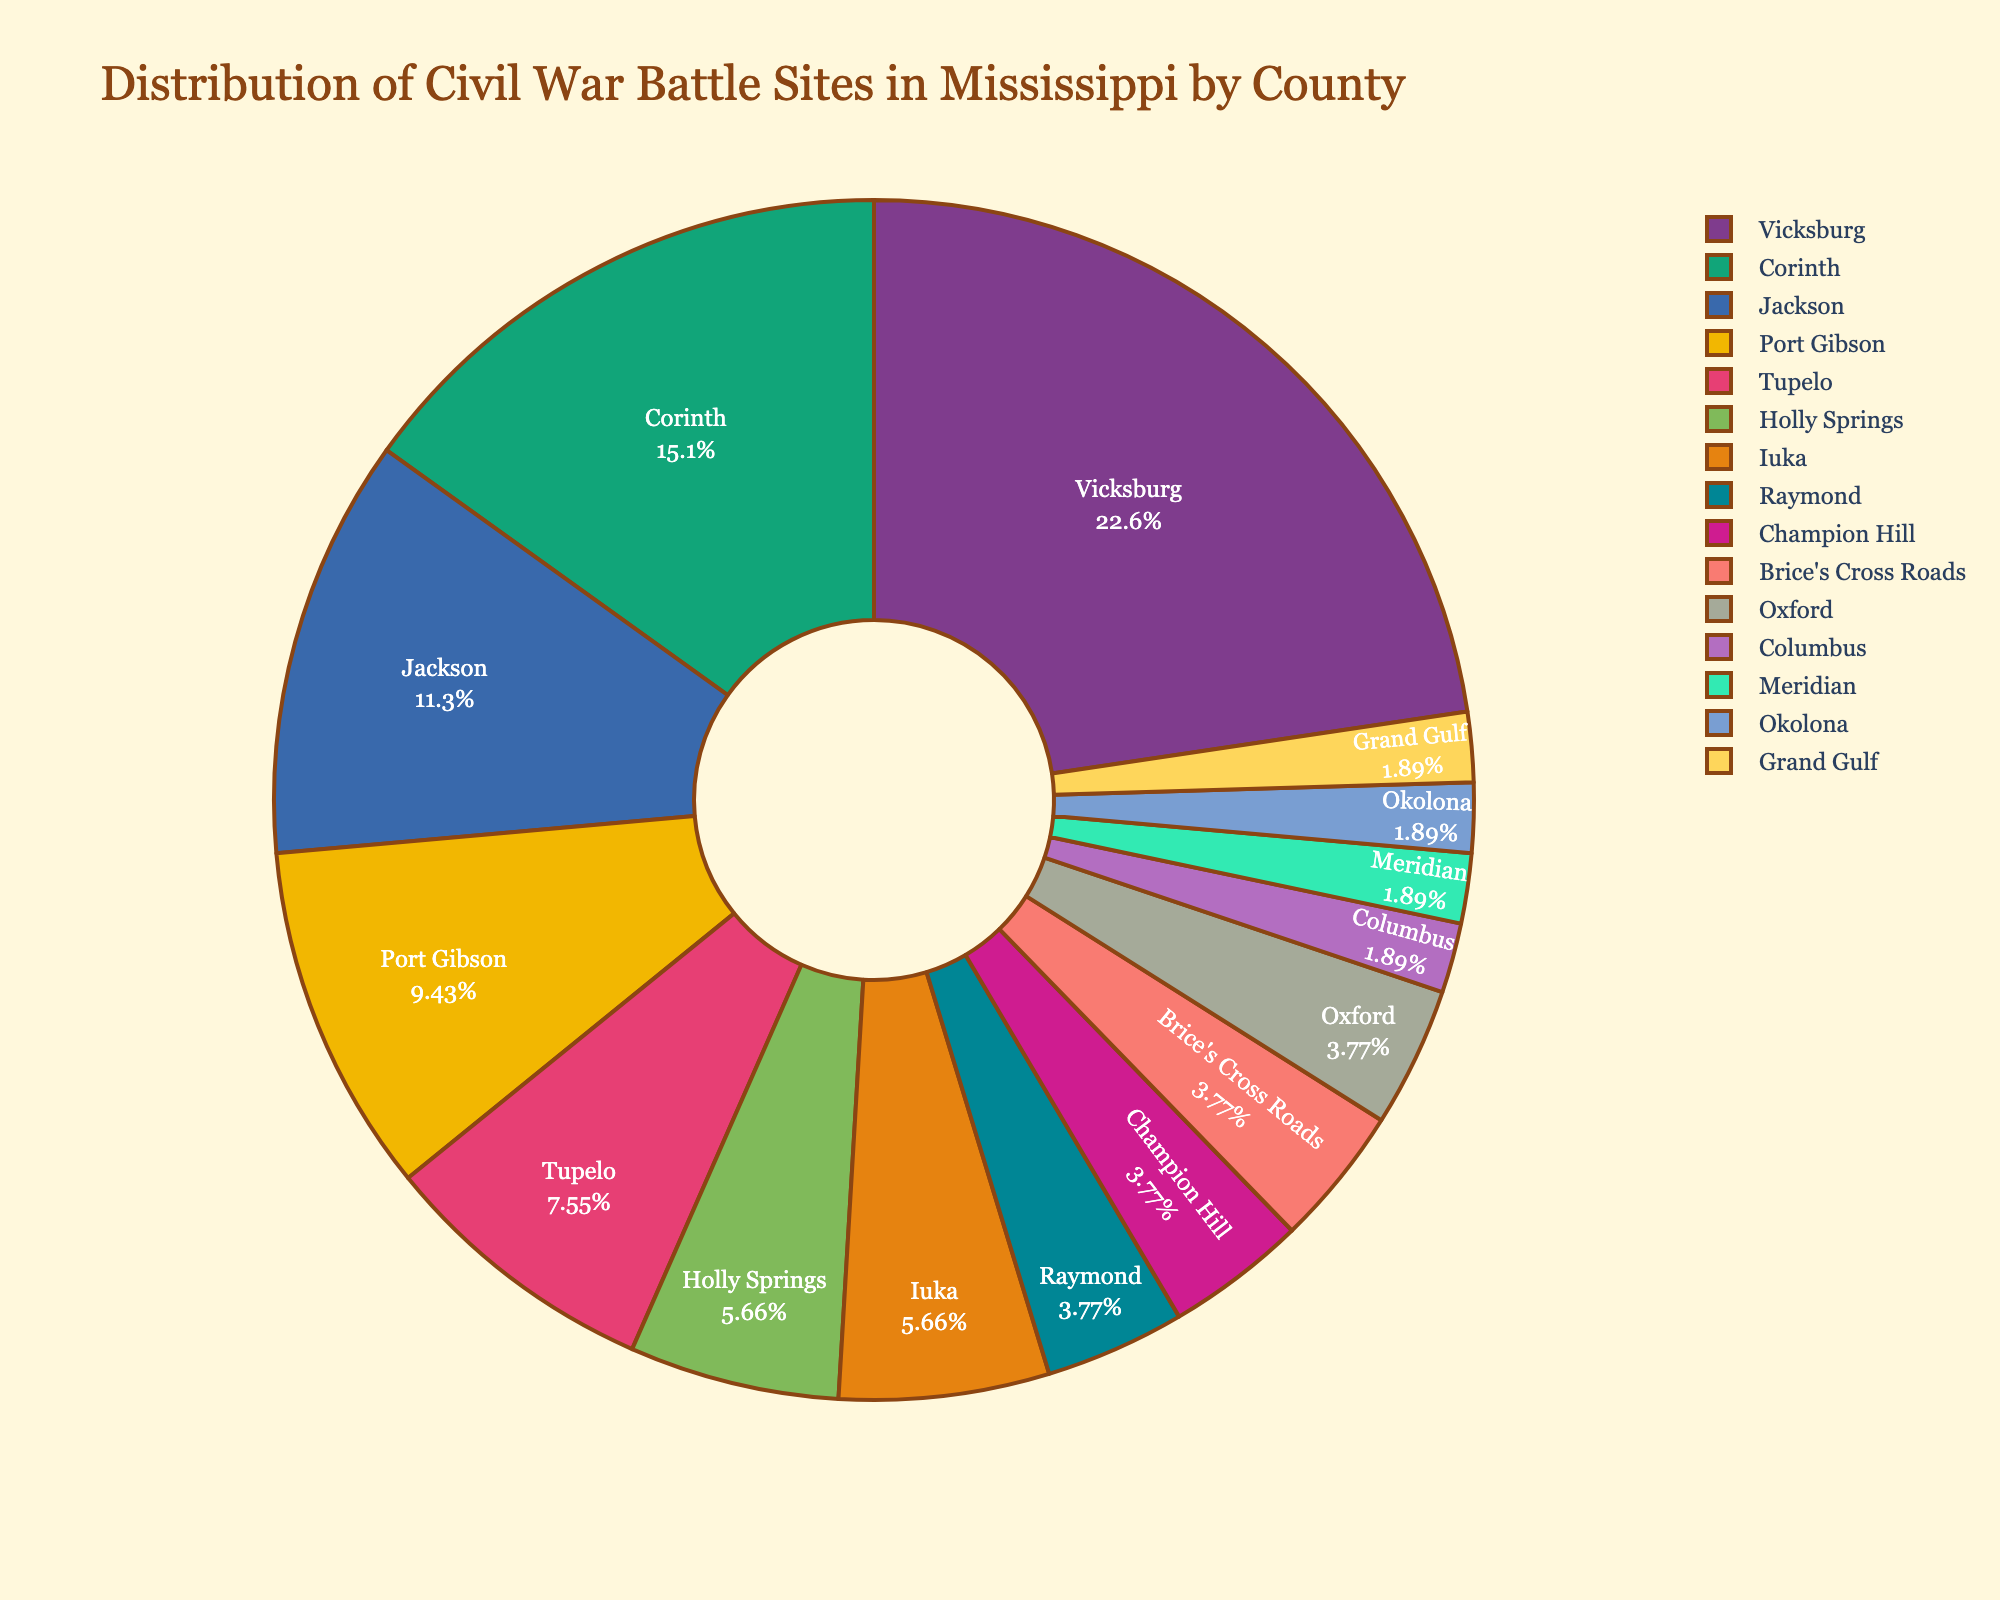What's the county with the highest number of Civil War battle sites? The figure shows that Vicksburg has the largest portion of the pie chart, indicating it has the highest number of battle sites.
Answer: Vicksburg Which two counties have the same number of Civil War battle sites and what is that number? By examining the sizes of each segment, it is evident that both Holly Springs and Iuka have equal-sized portions, each representing the same number of battle sites.
Answer: Holly Springs and Iuka, 3 What percentage of Civil War battle sites are in Vicksburg? The pie chart shows the percentage inside the Vicksburg segment. It is labeled directly in the figure.
Answer: 24% How many total battle sites are represented in the pie chart? Adding up all the numbers from each county gives: 12 (Vicksburg) + 8 (Corinth) + 6 (Jackson) + 5 (Port Gibson) + 4 (Tupelo) + 3 (Holly Springs) + 3 (Iuka) + 2 (Raymond) + 2 (Champion Hill) + 2 (Brice's Cross Roads) + 2 (Oxford) + 1 (Columbus) + 1 (Meridian) + 1 (Okolona) + 1 (Grand Gulf) = 53.
Answer: 53 Which county has the smallest percentage of battle sites and what is the percentage? By looking at the smallest slices on the pie chart, each representing the counties with a single battle site, these counties show the same smallest percentage. The pie chart segment labels show this as approximately 2%.
Answer: Columbus, Meridian, Okolona, Grand Gulf, 2% How many more battle sites does Vicksburg have compared to Jackson? Vicksburg has 12 battle sites and Jackson has 6. The difference can be calculated as 12 - 6.
Answer: 6 If you combine the battle sites from Corinth and Tupelo, how does that total compare to the number in Vicksburg? Adding the number of battle sites in Corinth (8) and Tupelo (4) gives 8 + 4 = 12, which is equal to the number of battle sites in Vicksburg.
Answer: Equal How many battle sites are there in counties with exactly two battle sites each? The counties are Raymond, Champion Hill, Brice's Cross Roads, and Oxford, each with 2 battle sites. Adding these together: 2 + 2 + 2 + 2 = 8.
Answer: 8 Which three counties have the next largest number of battle sites after Vicksburg and what are their respective numbers? The pie chart shows that the second largest segment corresponds to Corinth (8), followed by Jackson (6), and then Port Gibson (5).
Answer: Corinth (8), Jackson (6), Port Gibson (5) What is the combined percentage of battle sites in Raymond and Champion Hill? From the figure, each of these counties contributes to 2% of the pie chart. Combined, this percentage is 2% + 2%.
Answer: 4% 